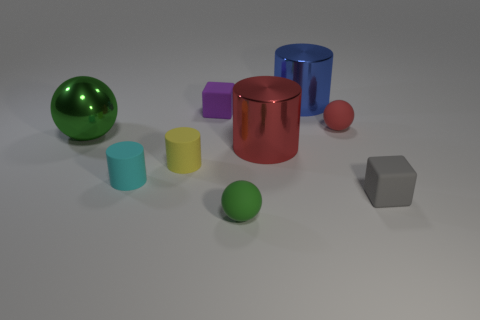Subtract all yellow cylinders. How many cylinders are left? 3 Subtract 2 cylinders. How many cylinders are left? 2 Subtract all blue cylinders. How many green spheres are left? 2 Subtract all yellow cylinders. How many cylinders are left? 3 Add 1 gray blocks. How many objects exist? 10 Subtract all spheres. How many objects are left? 6 Subtract all yellow spheres. Subtract all purple cylinders. How many spheres are left? 3 Subtract all small balls. Subtract all blue objects. How many objects are left? 6 Add 5 small yellow matte cylinders. How many small yellow matte cylinders are left? 6 Add 9 small gray matte cylinders. How many small gray matte cylinders exist? 9 